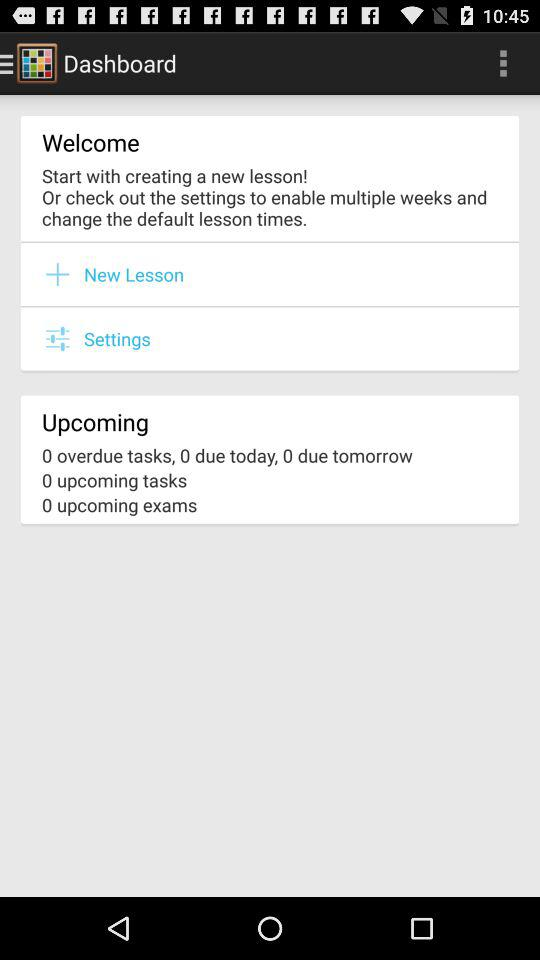Are there any upcoming exams? There are no upcoming exams. 